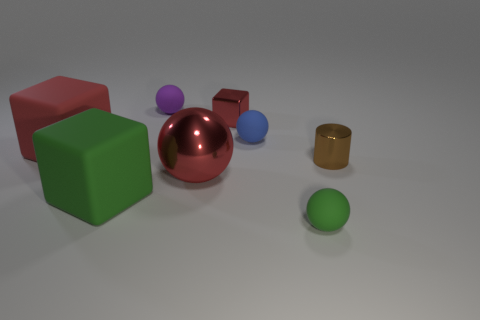What number of small balls are both in front of the red metal ball and left of the tiny red thing?
Give a very brief answer. 0. How many other objects are there of the same size as the blue rubber object?
Provide a succinct answer. 4. Does the green matte thing left of the purple matte ball have the same shape as the purple matte object that is to the left of the metallic sphere?
Keep it short and to the point. No. What number of objects are either big blue metallic spheres or balls that are behind the tiny green thing?
Your response must be concise. 3. There is a ball that is both behind the tiny green sphere and in front of the tiny brown cylinder; what material is it?
Keep it short and to the point. Metal. Is there anything else that has the same shape as the tiny red metal object?
Your response must be concise. Yes. The cylinder that is the same material as the tiny red thing is what color?
Keep it short and to the point. Brown. How many objects are either large red shiny things or tiny balls?
Provide a succinct answer. 4. Does the purple rubber ball have the same size as the green object that is on the left side of the green rubber sphere?
Offer a terse response. No. There is a metal thing in front of the brown cylinder in front of the small red block that is to the left of the brown metal object; what is its color?
Give a very brief answer. Red. 